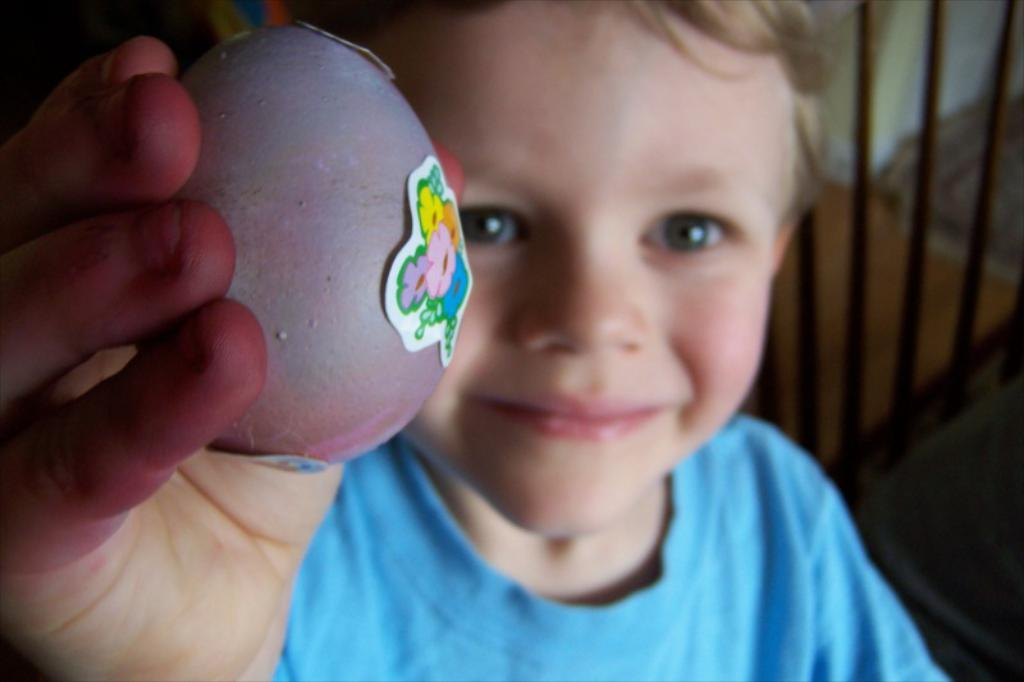What is the main subject of the picture? The main subject of the picture is a boy. What is the boy holding in his hand? The boy is holding an object in his hand. Can you describe the background of the boy? The background of the boy is blurred. How many spiders can be seen crawling on the boy's pocket in the image? There are no spiders visible in the image, and the boy is not shown wearing a pocket. 